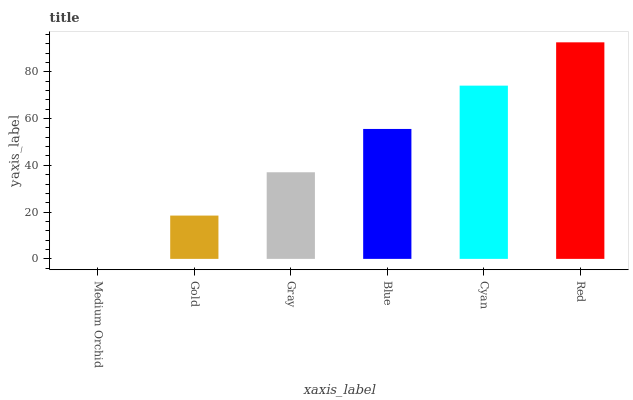Is Medium Orchid the minimum?
Answer yes or no. Yes. Is Red the maximum?
Answer yes or no. Yes. Is Gold the minimum?
Answer yes or no. No. Is Gold the maximum?
Answer yes or no. No. Is Gold greater than Medium Orchid?
Answer yes or no. Yes. Is Medium Orchid less than Gold?
Answer yes or no. Yes. Is Medium Orchid greater than Gold?
Answer yes or no. No. Is Gold less than Medium Orchid?
Answer yes or no. No. Is Blue the high median?
Answer yes or no. Yes. Is Gray the low median?
Answer yes or no. Yes. Is Medium Orchid the high median?
Answer yes or no. No. Is Blue the low median?
Answer yes or no. No. 